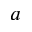Convert formula to latex. <formula><loc_0><loc_0><loc_500><loc_500>a</formula> 